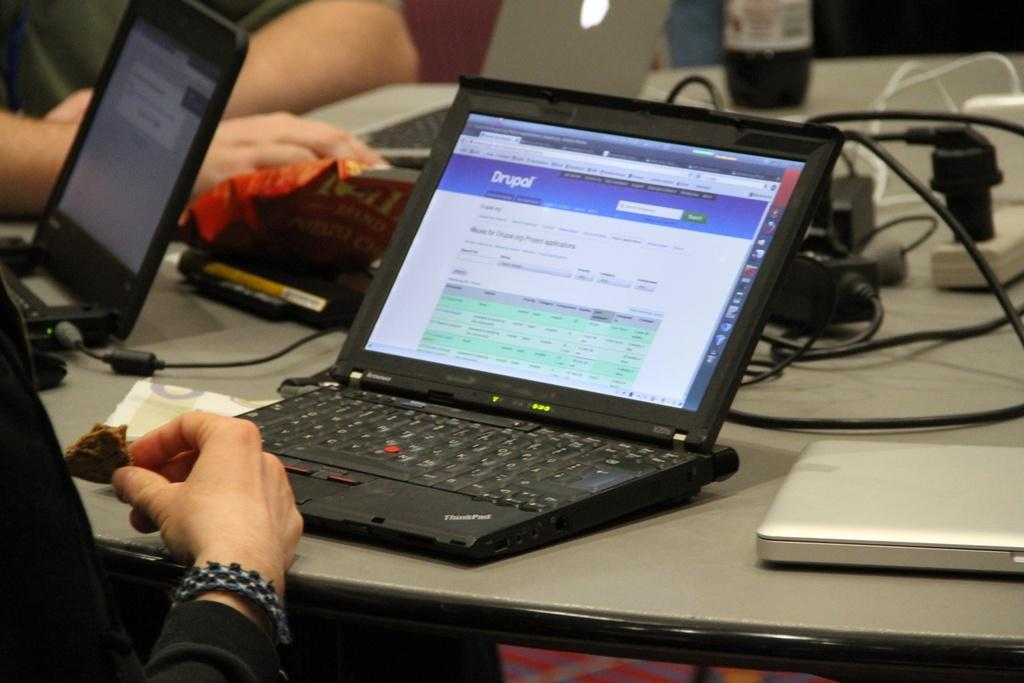<image>
Describe the image concisely. The person sitting at this laptop is looking at a webpage called Drupal. 